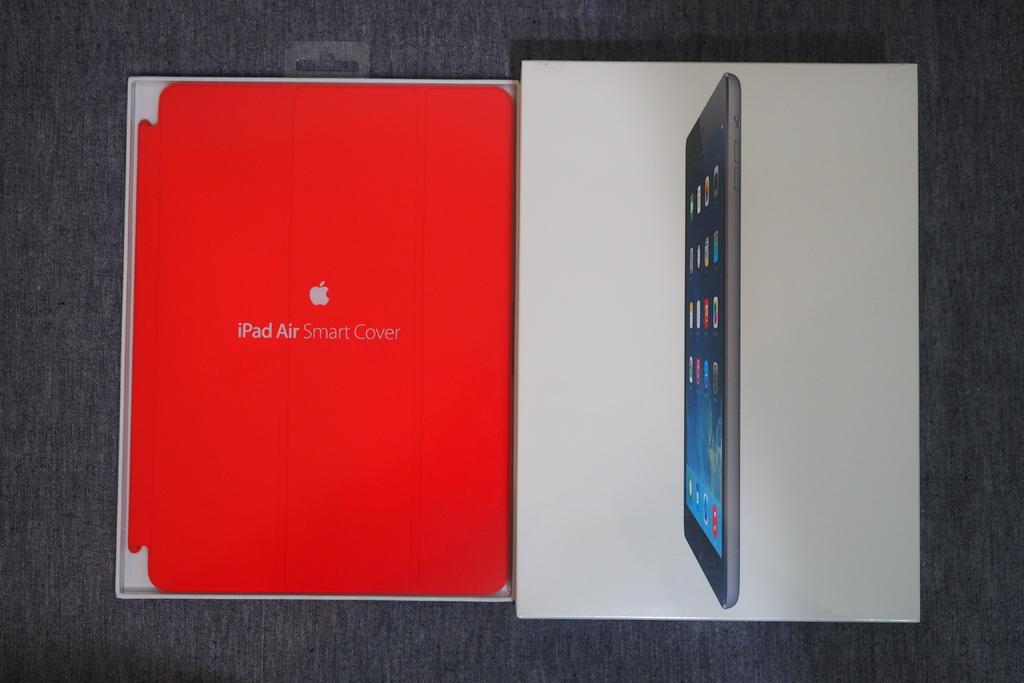<image>
Describe the image concisely. An iPad air smart cover and a box for an iPad. 